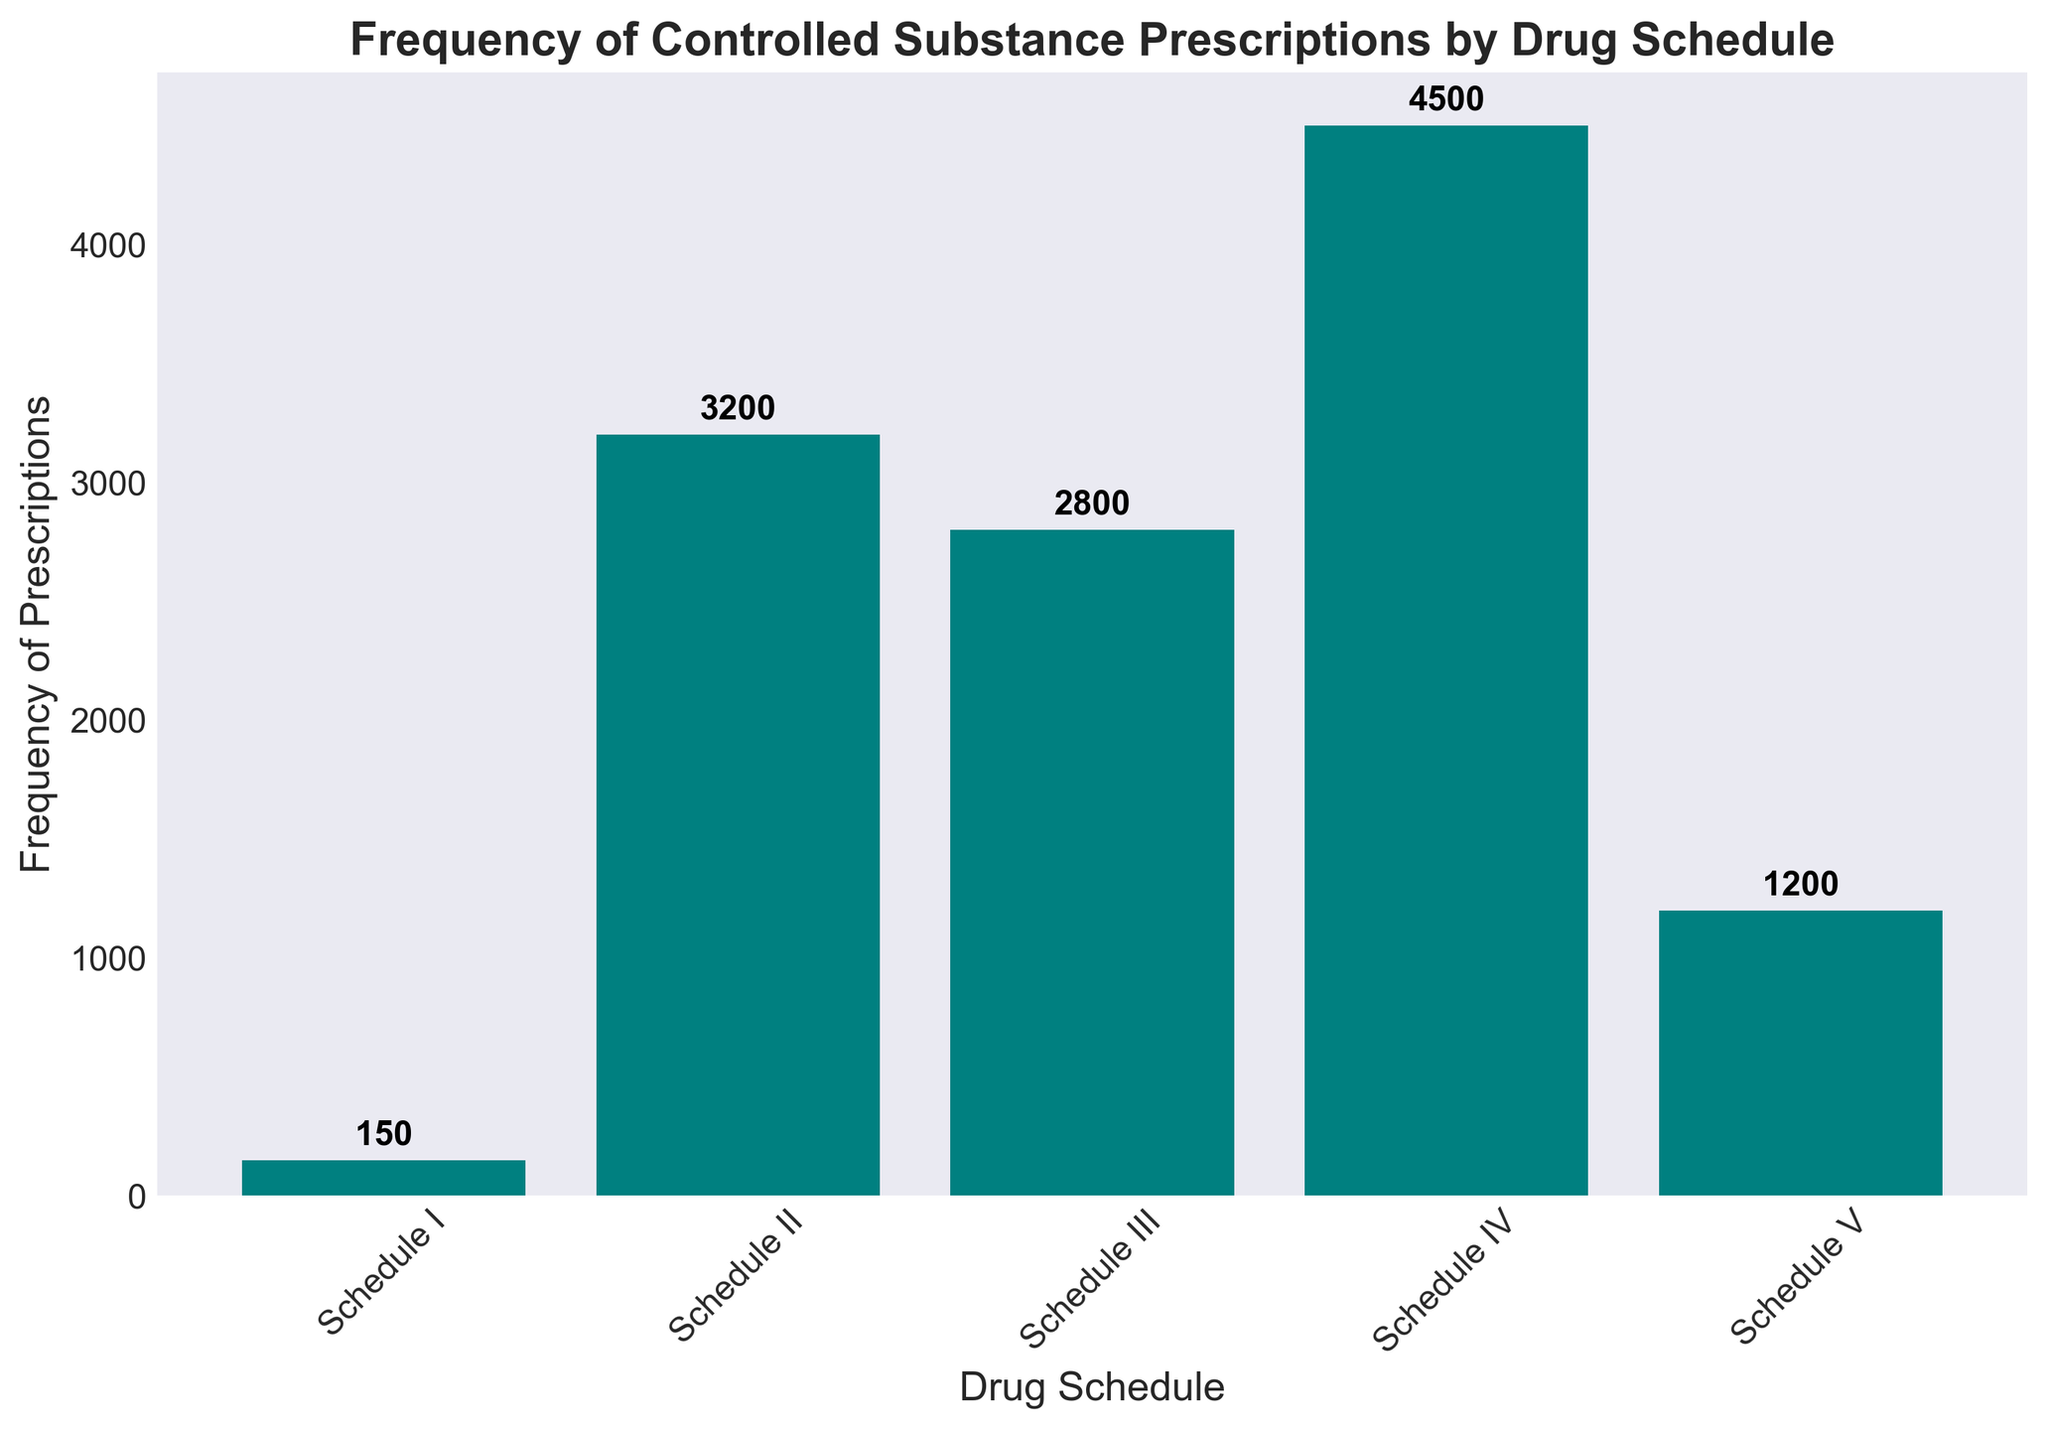What is the most frequently prescribed drug schedule? The bar corresponding to Schedule IV is the tallest among all, indicating it has the highest frequency of 4500 prescriptions.
Answer: Schedule IV What is the least frequently prescribed drug schedule? The bar corresponding to Schedule I is the shortest among all, indicating it has the lowest frequency of 150 prescriptions.
Answer: Schedule I How much more frequent are Schedule II prescriptions compared to Schedule V prescriptions? The height of the bar for Schedule II is 3200 and for Schedule V is 1200. Subtracting these values, 3200 - 1200 = 2000.
Answer: 2000 What is the average frequency of prescriptions across all drug schedules? Adding the frequencies of all drug schedules: 150 (Schedule I) + 3200 (Schedule II) + 2800 (Schedule III) + 4500 (Schedule IV) + 1200 (Schedule V) = 11850. Dividing by the number of schedules, 11850 / 5 = 2370.
Answer: 2370 Which schedules have frequencies greater than 3000? The bars for Schedule II (3200), Schedule III (2800), and Schedule IV (4500) are greater than 3000, but only Schedule II and Schedule IV actually exceed 3000.
Answer: Schedule II, Schedule IV What is the total frequency of Schedule III and Schedule V prescriptions combined? Adding the frequencies of Schedule III and Schedule V: 2800 (Schedule III) + 1200 (Schedule V) = 4000.
Answer: 4000 How does the frequency of Schedule III prescriptions compare with Schedule II prescriptions? The height of the bar for Schedule III is 2800, while for Schedule II it is 3200. Therefore, Schedule II has a higher frequency than Schedule III.
Answer: Schedule II has a higher frequency By how much is the frequency of Schedule IV prescriptions higher than the average frequency? The average frequency is 2370. The frequency of Schedule IV is 4500. Subtracting these values: 4500 - 2370 = 2130.
Answer: 2130 What is the visual trend observed in the frequencies of the drug schedules? From the bar chart, it's observed that the frequencies generally increase from Schedule I (150) to Schedule IV (4500), peaking at Schedule IV and then decreasing to Schedule V (1200).
Answer: Increasing trend from Schedule I to IV, then decreasing for Schedule V 